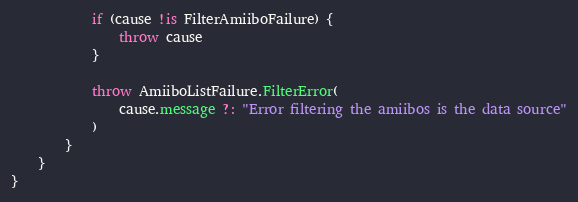Convert code to text. <code><loc_0><loc_0><loc_500><loc_500><_Kotlin_>            if (cause !is FilterAmiiboFailure) {
                throw cause
            }

            throw AmiiboListFailure.FilterError(
                cause.message ?: "Error filtering the amiibos is the data source"
            )
        }
    }
}
</code> 